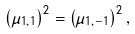<formula> <loc_0><loc_0><loc_500><loc_500>\left ( \mu _ { 1 , 1 } \right ) ^ { 2 } = \left ( \mu _ { 1 , - 1 } \right ) ^ { 2 } ,</formula> 